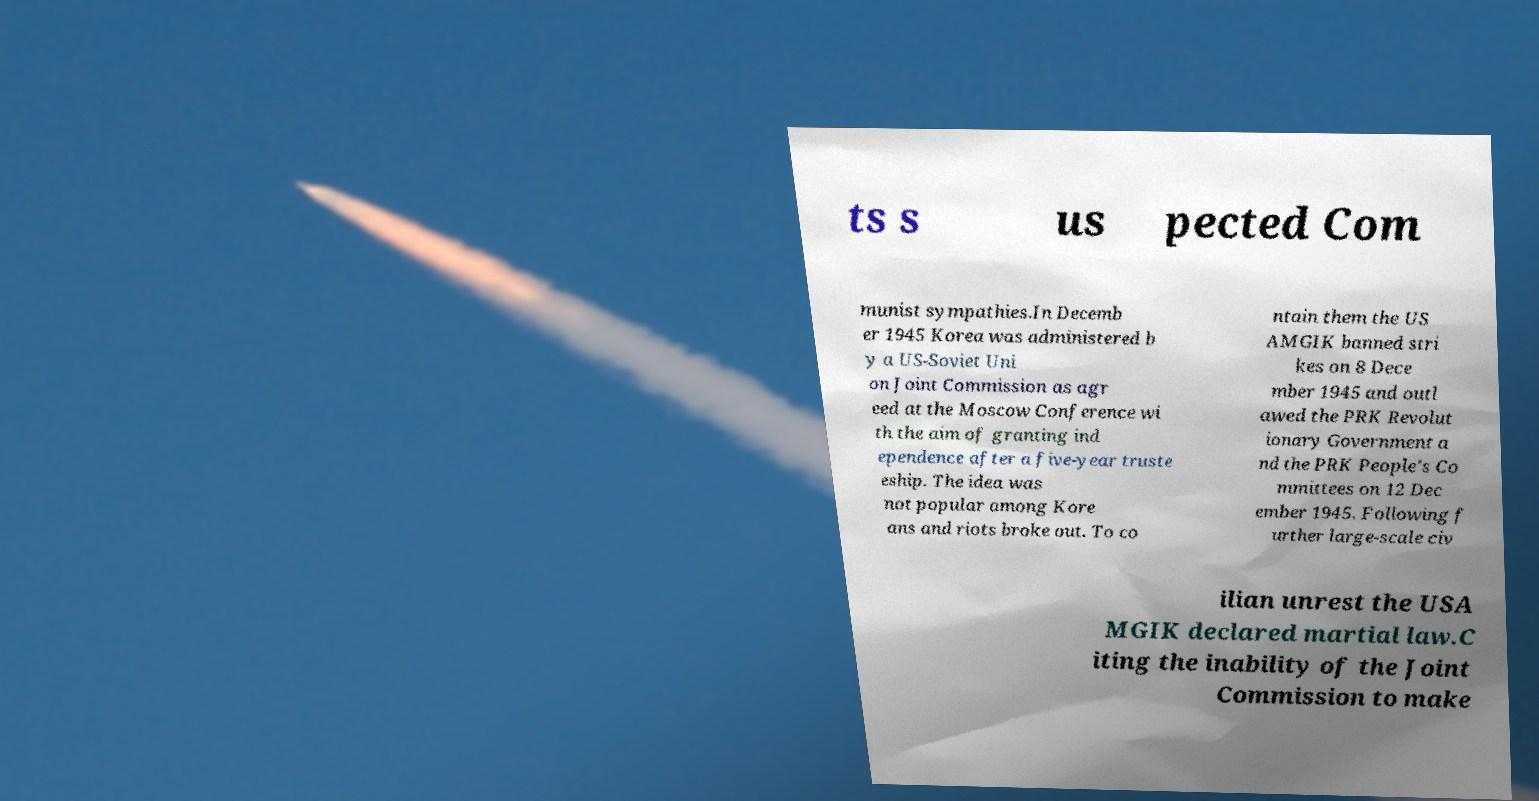Please identify and transcribe the text found in this image. ts s us pected Com munist sympathies.In Decemb er 1945 Korea was administered b y a US-Soviet Uni on Joint Commission as agr eed at the Moscow Conference wi th the aim of granting ind ependence after a five-year truste eship. The idea was not popular among Kore ans and riots broke out. To co ntain them the US AMGIK banned stri kes on 8 Dece mber 1945 and outl awed the PRK Revolut ionary Government a nd the PRK People's Co mmittees on 12 Dec ember 1945. Following f urther large-scale civ ilian unrest the USA MGIK declared martial law.C iting the inability of the Joint Commission to make 